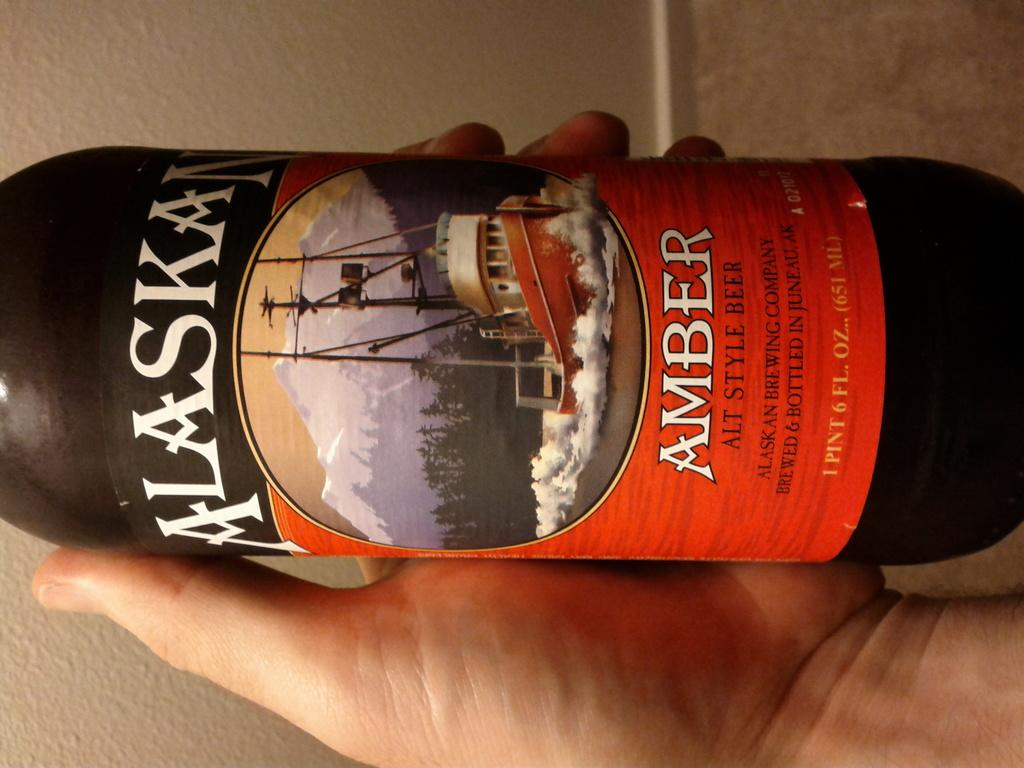<image>
Describe the image concisely. Someone holding a bottle of Alaskan beer that has a ship on the front. 